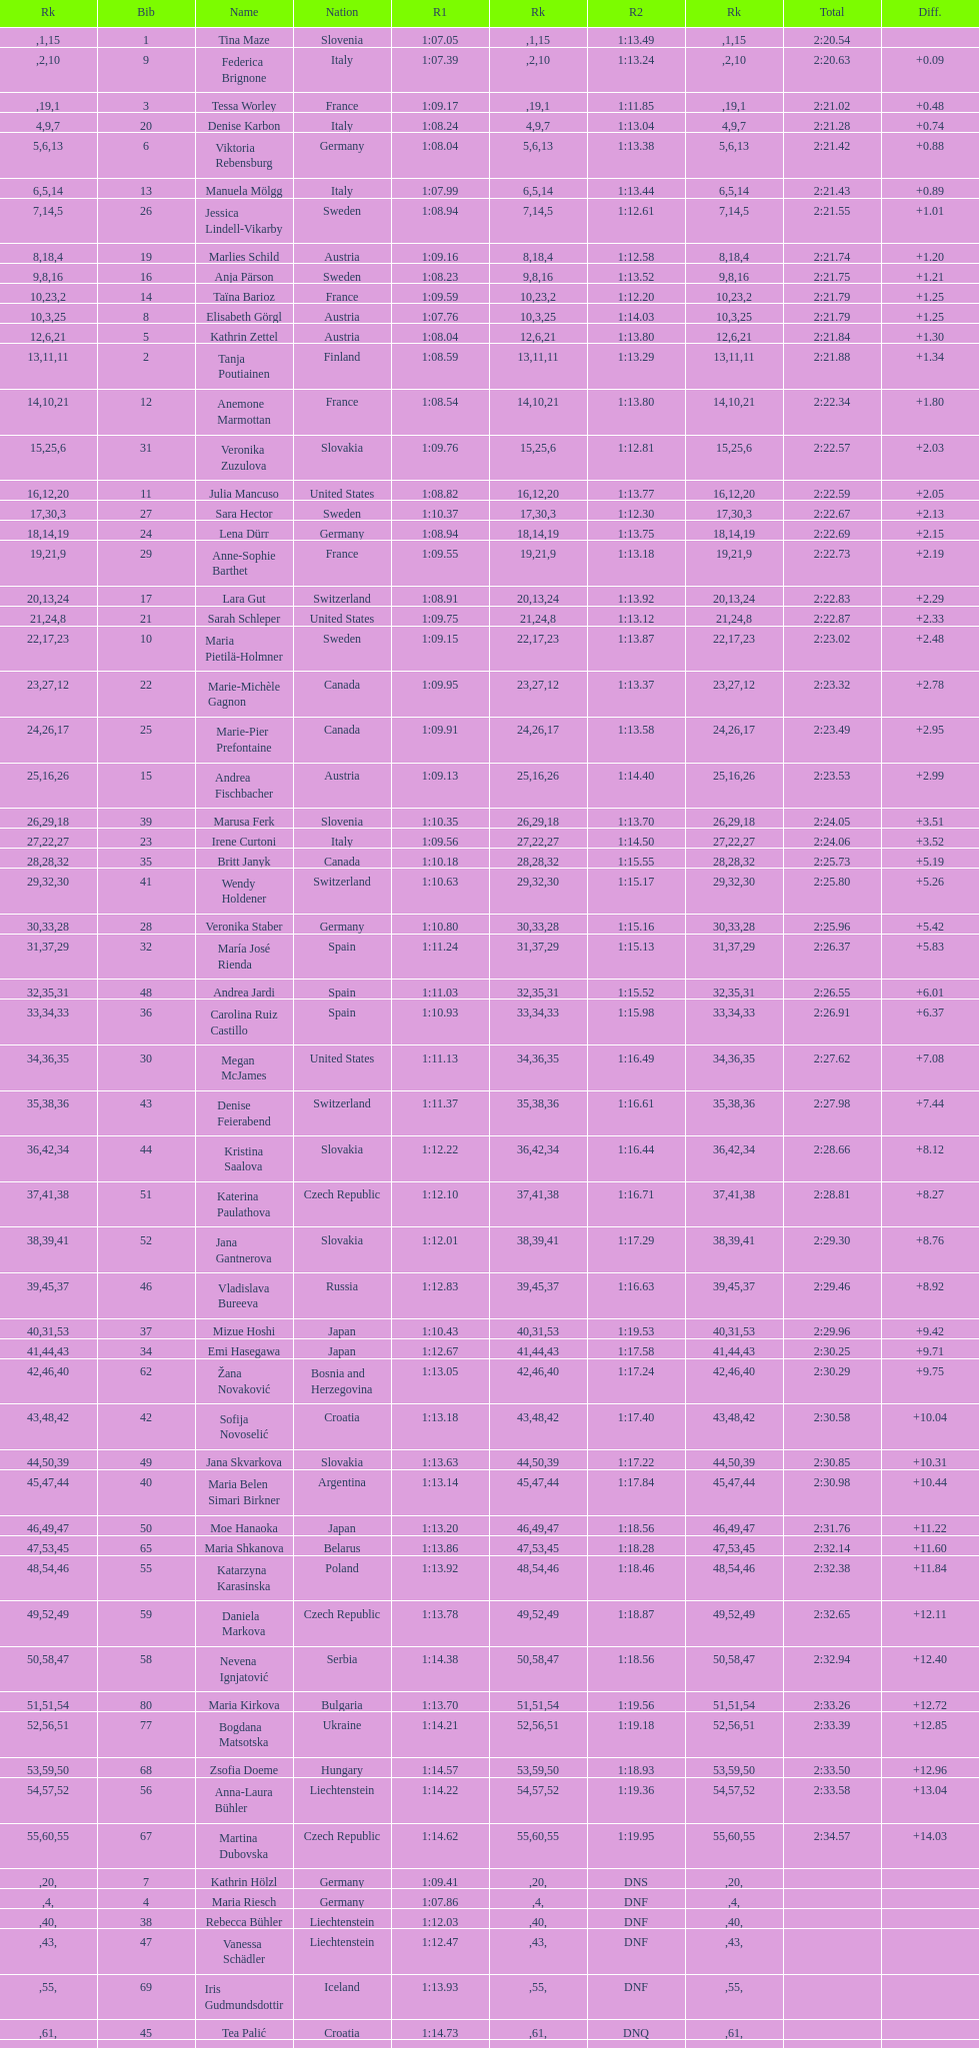Can you give me this table as a dict? {'header': ['Rk', 'Bib', 'Name', 'Nation', 'R1', 'Rk', 'R2', 'Rk', 'Total', 'Diff.'], 'rows': [['', '1', 'Tina Maze', 'Slovenia', '1:07.05', '1', '1:13.49', '15', '2:20.54', ''], ['', '9', 'Federica Brignone', 'Italy', '1:07.39', '2', '1:13.24', '10', '2:20.63', '+0.09'], ['', '3', 'Tessa Worley', 'France', '1:09.17', '19', '1:11.85', '1', '2:21.02', '+0.48'], ['4', '20', 'Denise Karbon', 'Italy', '1:08.24', '9', '1:13.04', '7', '2:21.28', '+0.74'], ['5', '6', 'Viktoria Rebensburg', 'Germany', '1:08.04', '6', '1:13.38', '13', '2:21.42', '+0.88'], ['6', '13', 'Manuela Mölgg', 'Italy', '1:07.99', '5', '1:13.44', '14', '2:21.43', '+0.89'], ['7', '26', 'Jessica Lindell-Vikarby', 'Sweden', '1:08.94', '14', '1:12.61', '5', '2:21.55', '+1.01'], ['8', '19', 'Marlies Schild', 'Austria', '1:09.16', '18', '1:12.58', '4', '2:21.74', '+1.20'], ['9', '16', 'Anja Pärson', 'Sweden', '1:08.23', '8', '1:13.52', '16', '2:21.75', '+1.21'], ['10', '14', 'Taïna Barioz', 'France', '1:09.59', '23', '1:12.20', '2', '2:21.79', '+1.25'], ['10', '8', 'Elisabeth Görgl', 'Austria', '1:07.76', '3', '1:14.03', '25', '2:21.79', '+1.25'], ['12', '5', 'Kathrin Zettel', 'Austria', '1:08.04', '6', '1:13.80', '21', '2:21.84', '+1.30'], ['13', '2', 'Tanja Poutiainen', 'Finland', '1:08.59', '11', '1:13.29', '11', '2:21.88', '+1.34'], ['14', '12', 'Anemone Marmottan', 'France', '1:08.54', '10', '1:13.80', '21', '2:22.34', '+1.80'], ['15', '31', 'Veronika Zuzulova', 'Slovakia', '1:09.76', '25', '1:12.81', '6', '2:22.57', '+2.03'], ['16', '11', 'Julia Mancuso', 'United States', '1:08.82', '12', '1:13.77', '20', '2:22.59', '+2.05'], ['17', '27', 'Sara Hector', 'Sweden', '1:10.37', '30', '1:12.30', '3', '2:22.67', '+2.13'], ['18', '24', 'Lena Dürr', 'Germany', '1:08.94', '14', '1:13.75', '19', '2:22.69', '+2.15'], ['19', '29', 'Anne-Sophie Barthet', 'France', '1:09.55', '21', '1:13.18', '9', '2:22.73', '+2.19'], ['20', '17', 'Lara Gut', 'Switzerland', '1:08.91', '13', '1:13.92', '24', '2:22.83', '+2.29'], ['21', '21', 'Sarah Schleper', 'United States', '1:09.75', '24', '1:13.12', '8', '2:22.87', '+2.33'], ['22', '10', 'Maria Pietilä-Holmner', 'Sweden', '1:09.15', '17', '1:13.87', '23', '2:23.02', '+2.48'], ['23', '22', 'Marie-Michèle Gagnon', 'Canada', '1:09.95', '27', '1:13.37', '12', '2:23.32', '+2.78'], ['24', '25', 'Marie-Pier Prefontaine', 'Canada', '1:09.91', '26', '1:13.58', '17', '2:23.49', '+2.95'], ['25', '15', 'Andrea Fischbacher', 'Austria', '1:09.13', '16', '1:14.40', '26', '2:23.53', '+2.99'], ['26', '39', 'Marusa Ferk', 'Slovenia', '1:10.35', '29', '1:13.70', '18', '2:24.05', '+3.51'], ['27', '23', 'Irene Curtoni', 'Italy', '1:09.56', '22', '1:14.50', '27', '2:24.06', '+3.52'], ['28', '35', 'Britt Janyk', 'Canada', '1:10.18', '28', '1:15.55', '32', '2:25.73', '+5.19'], ['29', '41', 'Wendy Holdener', 'Switzerland', '1:10.63', '32', '1:15.17', '30', '2:25.80', '+5.26'], ['30', '28', 'Veronika Staber', 'Germany', '1:10.80', '33', '1:15.16', '28', '2:25.96', '+5.42'], ['31', '32', 'María José Rienda', 'Spain', '1:11.24', '37', '1:15.13', '29', '2:26.37', '+5.83'], ['32', '48', 'Andrea Jardi', 'Spain', '1:11.03', '35', '1:15.52', '31', '2:26.55', '+6.01'], ['33', '36', 'Carolina Ruiz Castillo', 'Spain', '1:10.93', '34', '1:15.98', '33', '2:26.91', '+6.37'], ['34', '30', 'Megan McJames', 'United States', '1:11.13', '36', '1:16.49', '35', '2:27.62', '+7.08'], ['35', '43', 'Denise Feierabend', 'Switzerland', '1:11.37', '38', '1:16.61', '36', '2:27.98', '+7.44'], ['36', '44', 'Kristina Saalova', 'Slovakia', '1:12.22', '42', '1:16.44', '34', '2:28.66', '+8.12'], ['37', '51', 'Katerina Paulathova', 'Czech Republic', '1:12.10', '41', '1:16.71', '38', '2:28.81', '+8.27'], ['38', '52', 'Jana Gantnerova', 'Slovakia', '1:12.01', '39', '1:17.29', '41', '2:29.30', '+8.76'], ['39', '46', 'Vladislava Bureeva', 'Russia', '1:12.83', '45', '1:16.63', '37', '2:29.46', '+8.92'], ['40', '37', 'Mizue Hoshi', 'Japan', '1:10.43', '31', '1:19.53', '53', '2:29.96', '+9.42'], ['41', '34', 'Emi Hasegawa', 'Japan', '1:12.67', '44', '1:17.58', '43', '2:30.25', '+9.71'], ['42', '62', 'Žana Novaković', 'Bosnia and Herzegovina', '1:13.05', '46', '1:17.24', '40', '2:30.29', '+9.75'], ['43', '42', 'Sofija Novoselić', 'Croatia', '1:13.18', '48', '1:17.40', '42', '2:30.58', '+10.04'], ['44', '49', 'Jana Skvarkova', 'Slovakia', '1:13.63', '50', '1:17.22', '39', '2:30.85', '+10.31'], ['45', '40', 'Maria Belen Simari Birkner', 'Argentina', '1:13.14', '47', '1:17.84', '44', '2:30.98', '+10.44'], ['46', '50', 'Moe Hanaoka', 'Japan', '1:13.20', '49', '1:18.56', '47', '2:31.76', '+11.22'], ['47', '65', 'Maria Shkanova', 'Belarus', '1:13.86', '53', '1:18.28', '45', '2:32.14', '+11.60'], ['48', '55', 'Katarzyna Karasinska', 'Poland', '1:13.92', '54', '1:18.46', '46', '2:32.38', '+11.84'], ['49', '59', 'Daniela Markova', 'Czech Republic', '1:13.78', '52', '1:18.87', '49', '2:32.65', '+12.11'], ['50', '58', 'Nevena Ignjatović', 'Serbia', '1:14.38', '58', '1:18.56', '47', '2:32.94', '+12.40'], ['51', '80', 'Maria Kirkova', 'Bulgaria', '1:13.70', '51', '1:19.56', '54', '2:33.26', '+12.72'], ['52', '77', 'Bogdana Matsotska', 'Ukraine', '1:14.21', '56', '1:19.18', '51', '2:33.39', '+12.85'], ['53', '68', 'Zsofia Doeme', 'Hungary', '1:14.57', '59', '1:18.93', '50', '2:33.50', '+12.96'], ['54', '56', 'Anna-Laura Bühler', 'Liechtenstein', '1:14.22', '57', '1:19.36', '52', '2:33.58', '+13.04'], ['55', '67', 'Martina Dubovska', 'Czech Republic', '1:14.62', '60', '1:19.95', '55', '2:34.57', '+14.03'], ['', '7', 'Kathrin Hölzl', 'Germany', '1:09.41', '20', 'DNS', '', '', ''], ['', '4', 'Maria Riesch', 'Germany', '1:07.86', '4', 'DNF', '', '', ''], ['', '38', 'Rebecca Bühler', 'Liechtenstein', '1:12.03', '40', 'DNF', '', '', ''], ['', '47', 'Vanessa Schädler', 'Liechtenstein', '1:12.47', '43', 'DNF', '', '', ''], ['', '69', 'Iris Gudmundsdottir', 'Iceland', '1:13.93', '55', 'DNF', '', '', ''], ['', '45', 'Tea Palić', 'Croatia', '1:14.73', '61', 'DNQ', '', '', ''], ['', '74', 'Macarena Simari Birkner', 'Argentina', '1:15.18', '62', 'DNQ', '', '', ''], ['', '72', 'Lavinia Chrystal', 'Australia', '1:15.35', '63', 'DNQ', '', '', ''], ['', '81', 'Lelde Gasuna', 'Latvia', '1:15.37', '64', 'DNQ', '', '', ''], ['', '64', 'Aleksandra Klus', 'Poland', '1:15.41', '65', 'DNQ', '', '', ''], ['', '78', 'Nino Tsiklauri', 'Georgia', '1:15.54', '66', 'DNQ', '', '', ''], ['', '66', 'Sarah Jarvis', 'New Zealand', '1:15.94', '67', 'DNQ', '', '', ''], ['', '61', 'Anna Berecz', 'Hungary', '1:15.95', '68', 'DNQ', '', '', ''], ['', '83', 'Sandra-Elena Narea', 'Romania', '1:16.67', '69', 'DNQ', '', '', ''], ['', '85', 'Iulia Petruta Craciun', 'Romania', '1:16.80', '70', 'DNQ', '', '', ''], ['', '82', 'Isabel van Buynder', 'Belgium', '1:17.06', '71', 'DNQ', '', '', ''], ['', '97', 'Liene Fimbauere', 'Latvia', '1:17.83', '72', 'DNQ', '', '', ''], ['', '86', 'Kristina Krone', 'Puerto Rico', '1:17.93', '73', 'DNQ', '', '', ''], ['', '88', 'Nicole Valcareggi', 'Greece', '1:18.19', '74', 'DNQ', '', '', ''], ['', '100', 'Sophie Fjellvang-Sølling', 'Denmark', '1:18.37', '75', 'DNQ', '', '', ''], ['', '95', 'Ornella Oettl Reyes', 'Peru', '1:18.61', '76', 'DNQ', '', '', ''], ['', '73', 'Xia Lina', 'China', '1:19.12', '77', 'DNQ', '', '', ''], ['', '94', 'Kseniya Grigoreva', 'Uzbekistan', '1:19.16', '78', 'DNQ', '', '', ''], ['', '87', 'Tugba Dasdemir', 'Turkey', '1:21.50', '79', 'DNQ', '', '', ''], ['', '92', 'Malene Madsen', 'Denmark', '1:22.25', '80', 'DNQ', '', '', ''], ['', '84', 'Liu Yang', 'China', '1:22.80', '81', 'DNQ', '', '', ''], ['', '91', 'Yom Hirshfeld', 'Israel', '1:22.87', '82', 'DNQ', '', '', ''], ['', '75', 'Salome Bancora', 'Argentina', '1:23.08', '83', 'DNQ', '', '', ''], ['', '93', 'Ronnie Kiek-Gedalyahu', 'Israel', '1:23.38', '84', 'DNQ', '', '', ''], ['', '96', 'Chiara Marano', 'Brazil', '1:24.16', '85', 'DNQ', '', '', ''], ['', '113', 'Anne Libak Nielsen', 'Denmark', '1:25.08', '86', 'DNQ', '', '', ''], ['', '105', 'Donata Hellner', 'Hungary', '1:26.97', '87', 'DNQ', '', '', ''], ['', '102', 'Liu Yu', 'China', '1:27.03', '88', 'DNQ', '', '', ''], ['', '109', 'Lida Zvoznikova', 'Kyrgyzstan', '1:27.17', '89', 'DNQ', '', '', ''], ['', '103', 'Szelina Hellner', 'Hungary', '1:27.27', '90', 'DNQ', '', '', ''], ['', '114', 'Irina Volkova', 'Kyrgyzstan', '1:29.73', '91', 'DNQ', '', '', ''], ['', '106', 'Svetlana Baranova', 'Uzbekistan', '1:30.62', '92', 'DNQ', '', '', ''], ['', '108', 'Tatjana Baranova', 'Uzbekistan', '1:31.81', '93', 'DNQ', '', '', ''], ['', '110', 'Fatemeh Kiadarbandsari', 'Iran', '1:32.16', '94', 'DNQ', '', '', ''], ['', '107', 'Ziba Kalhor', 'Iran', '1:32.64', '95', 'DNQ', '', '', ''], ['', '104', 'Paraskevi Mavridou', 'Greece', '1:32.83', '96', 'DNQ', '', '', ''], ['', '99', 'Marjan Kalhor', 'Iran', '1:34.94', '97', 'DNQ', '', '', ''], ['', '112', 'Mitra Kalhor', 'Iran', '1:37.93', '98', 'DNQ', '', '', ''], ['', '115', 'Laura Bauer', 'South Africa', '1:42.19', '99', 'DNQ', '', '', ''], ['', '111', 'Sarah Ekmekejian', 'Lebanon', '1:42.22', '100', 'DNQ', '', '', ''], ['', '18', 'Fabienne Suter', 'Switzerland', 'DNS', '', '', '', '', ''], ['', '98', 'Maja Klepić', 'Bosnia and Herzegovina', 'DNS', '', '', '', '', ''], ['', '33', 'Agniezska Gasienica Daniel', 'Poland', 'DNF', '', '', '', '', ''], ['', '53', 'Karolina Chrapek', 'Poland', 'DNF', '', '', '', '', ''], ['', '54', 'Mireia Gutierrez', 'Andorra', 'DNF', '', '', '', '', ''], ['', '57', 'Brittany Phelan', 'Canada', 'DNF', '', '', '', '', ''], ['', '60', 'Tereza Kmochova', 'Czech Republic', 'DNF', '', '', '', '', ''], ['', '63', 'Michelle van Herwerden', 'Netherlands', 'DNF', '', '', '', '', ''], ['', '70', 'Maya Harrisson', 'Brazil', 'DNF', '', '', '', '', ''], ['', '71', 'Elizabeth Pilat', 'Australia', 'DNF', '', '', '', '', ''], ['', '76', 'Katrin Kristjansdottir', 'Iceland', 'DNF', '', '', '', '', ''], ['', '79', 'Julietta Quiroga', 'Argentina', 'DNF', '', '', '', '', ''], ['', '89', 'Evija Benhena', 'Latvia', 'DNF', '', '', '', '', ''], ['', '90', 'Qin Xiyue', 'China', 'DNF', '', '', '', '', ''], ['', '101', 'Sophia Ralli', 'Greece', 'DNF', '', '', '', '', ''], ['', '116', 'Siranush Maghakyan', 'Armenia', 'DNF', '', '', '', '', '']]} What was the number of swedes in the top fifteen? 2. 